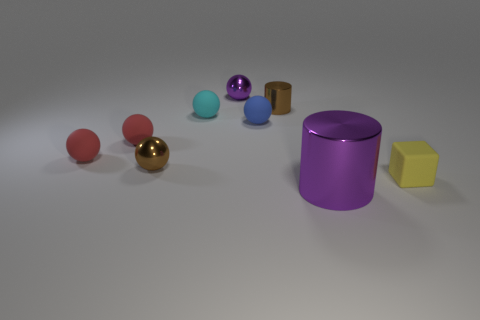What might be the purpose of the yellow cube? The yellow cube appears to be a simple geometric object, which suggests it might be used for educational purposes, such as teaching about shapes and volume, or as a decorative element due to its bright color. 